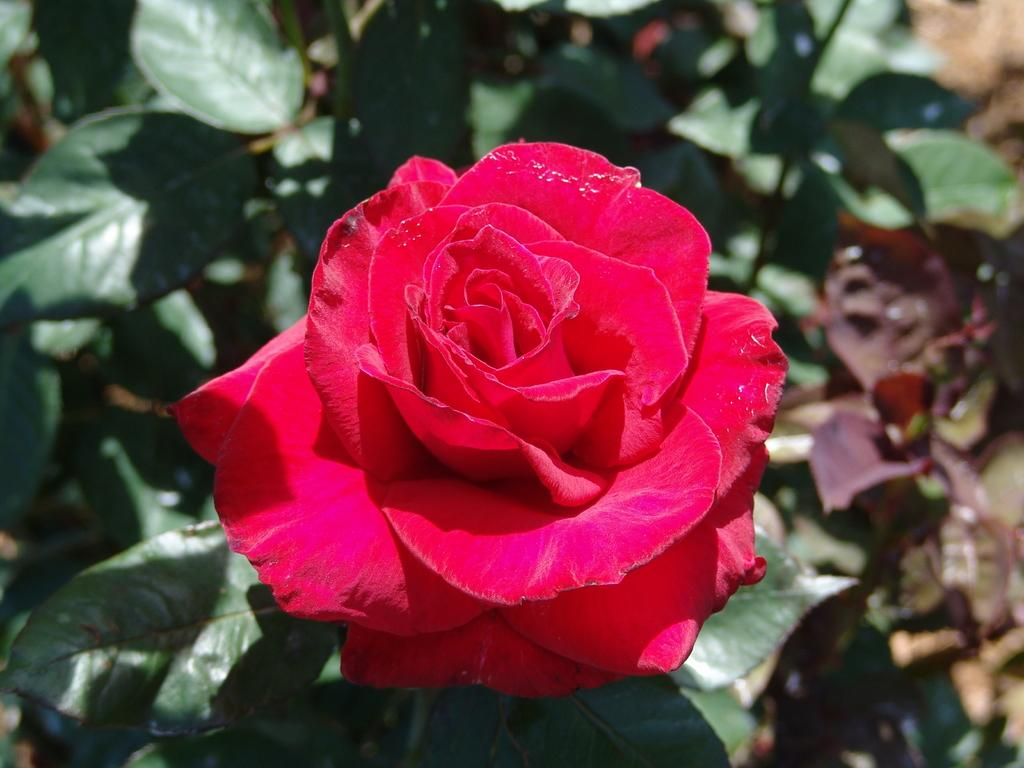What type of flower is in the image? There is a red color rose in the image. What else can be seen in the image besides the rose? There are plants in the image. What type of key is used to open the dirt in the image? There is no key or dirt present in the image; it only features a red color rose and other plants. 